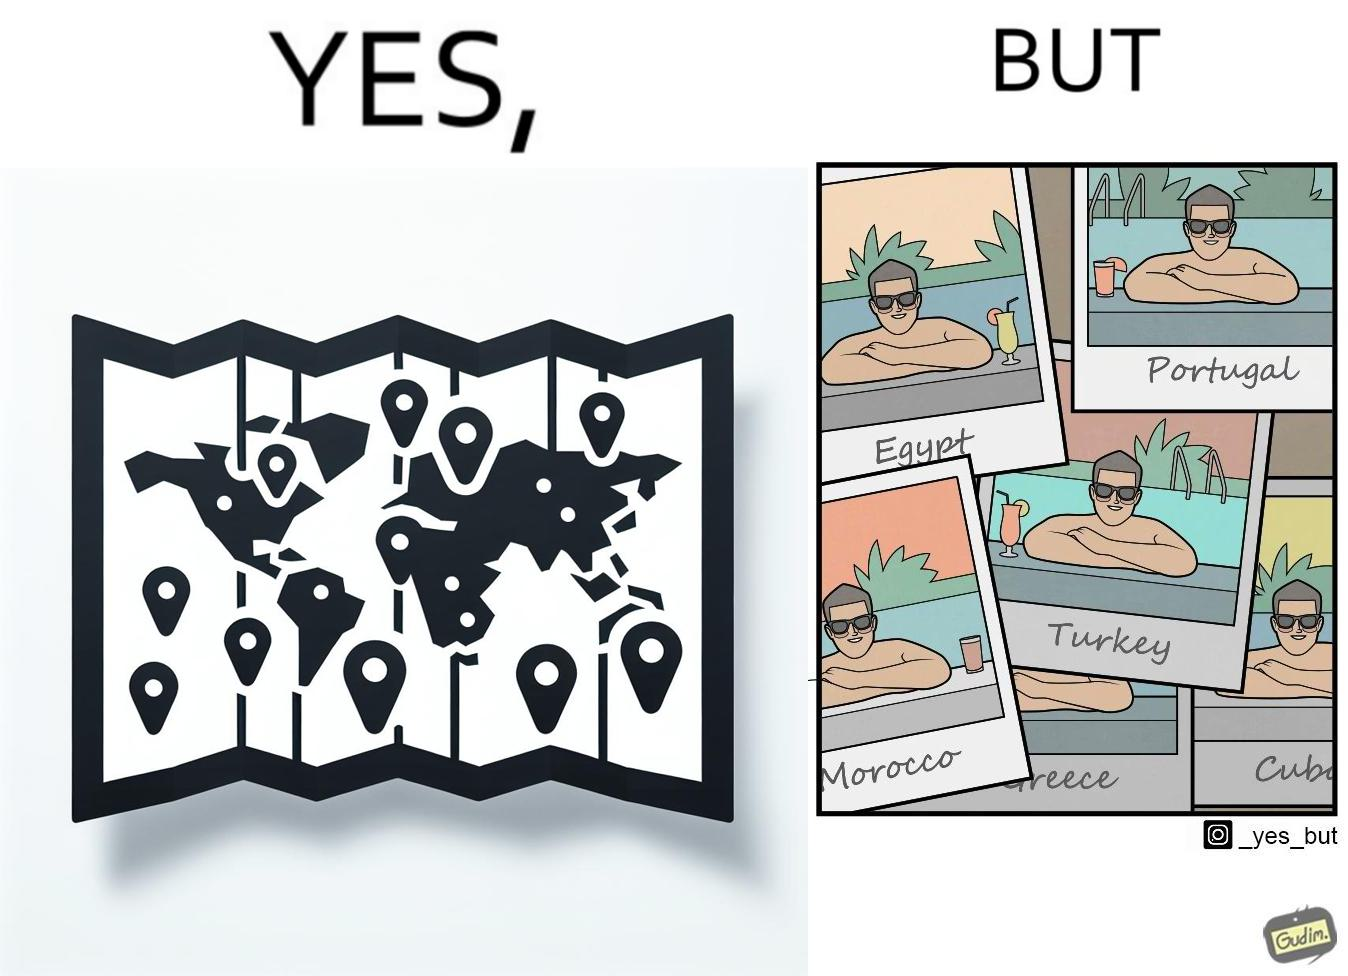Describe what you see in the left and right parts of this image. In the left part of the image: The image shows a map with pins set on places which have been visited by a person. In the right part of the image: The image shows several photos of a man wearing sunglasses  inside a pool in various countries like Egypt, Portugal, Morocco, Turkey, Greece and Cuba. 